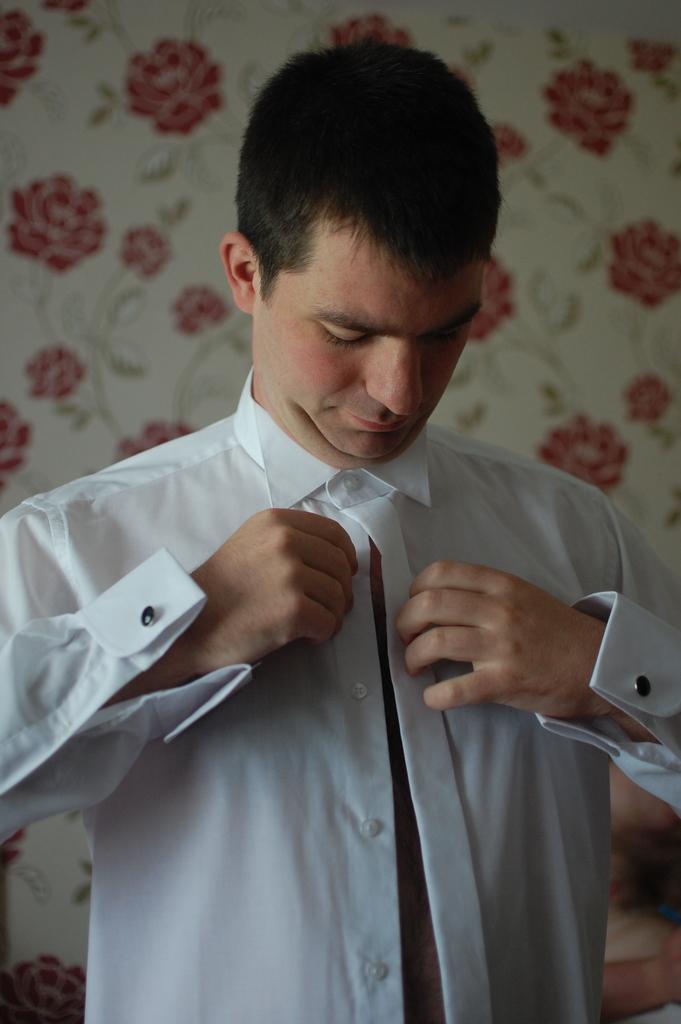Can you describe this image briefly? In this image I see a man who is wearing white shirt and in the background I see the wall on which there are designs of flowers. 